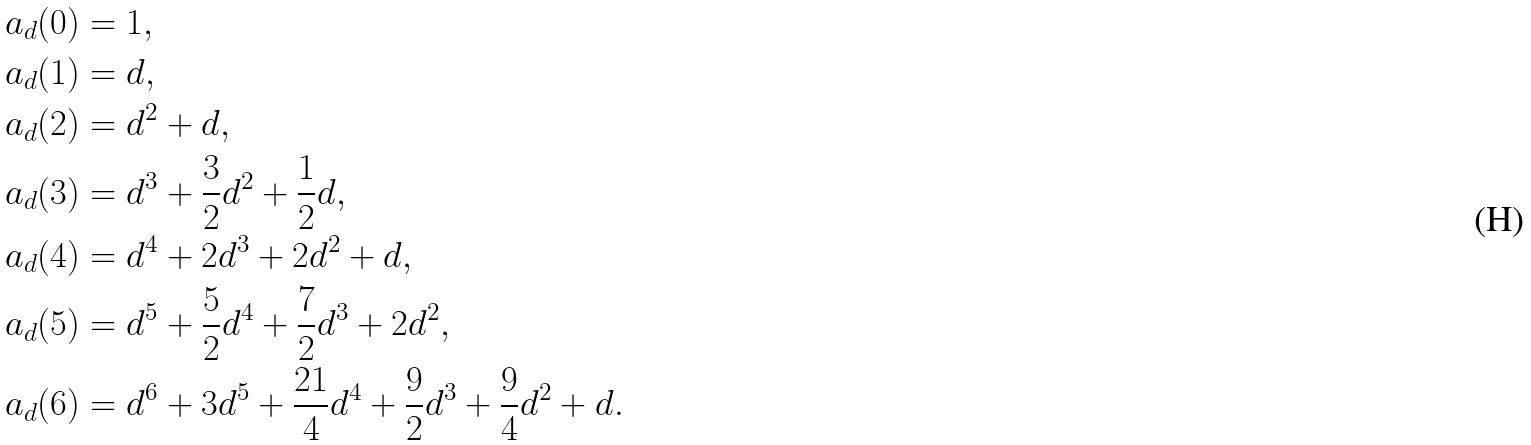Convert formula to latex. <formula><loc_0><loc_0><loc_500><loc_500>a _ { d } ( 0 ) & = 1 , \\ a _ { d } ( 1 ) & = d , \\ a _ { d } ( 2 ) & = d ^ { 2 } + d , \\ a _ { d } ( 3 ) & = d ^ { 3 } + \frac { 3 } { 2 } d ^ { 2 } + \frac { 1 } { 2 } d , \\ a _ { d } ( 4 ) & = d ^ { 4 } + 2 d ^ { 3 } + 2 d ^ { 2 } + d , \\ a _ { d } ( 5 ) & = d ^ { 5 } + \frac { 5 } { 2 } d ^ { 4 } + \frac { 7 } { 2 } d ^ { 3 } + 2 d ^ { 2 } , \\ a _ { d } ( 6 ) & = d ^ { 6 } + 3 d ^ { 5 } + \frac { 2 1 } { 4 } d ^ { 4 } + \frac { 9 } { 2 } d ^ { 3 } + \frac { 9 } { 4 } d ^ { 2 } + d .</formula> 